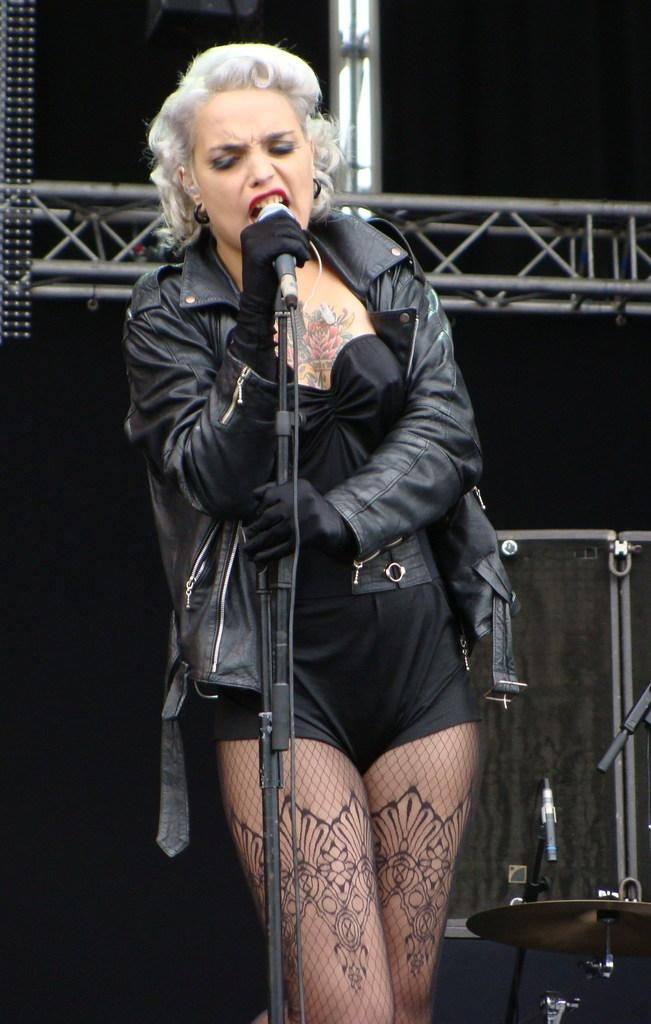What is the main subject of the image? The main subject of the image is a woman. What is the woman wearing? The woman is wearing a black jacket. What is the woman holding in the image? The woman is holding a microphone. What is the woman doing in the image? The woman is singing. What other objects related to music can be seen in the image? There are rods, a microphone holder, and musical instruments in the image. What type of underwear is the woman wearing in the image? There is no information about the woman's underwear in the image, and therefore it cannot be determined. Is there a bomb visible in the image? No, there is no bomb present in the image. 